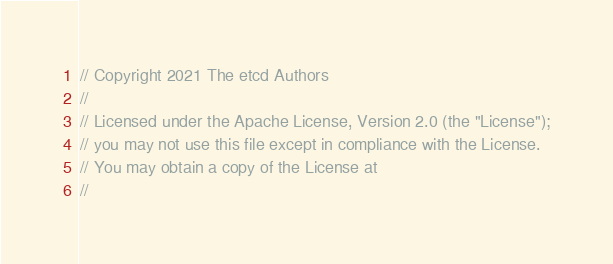<code> <loc_0><loc_0><loc_500><loc_500><_Go_>// Copyright 2021 The etcd Authors
//
// Licensed under the Apache License, Version 2.0 (the "License");
// you may not use this file except in compliance with the License.
// You may obtain a copy of the License at
//</code> 